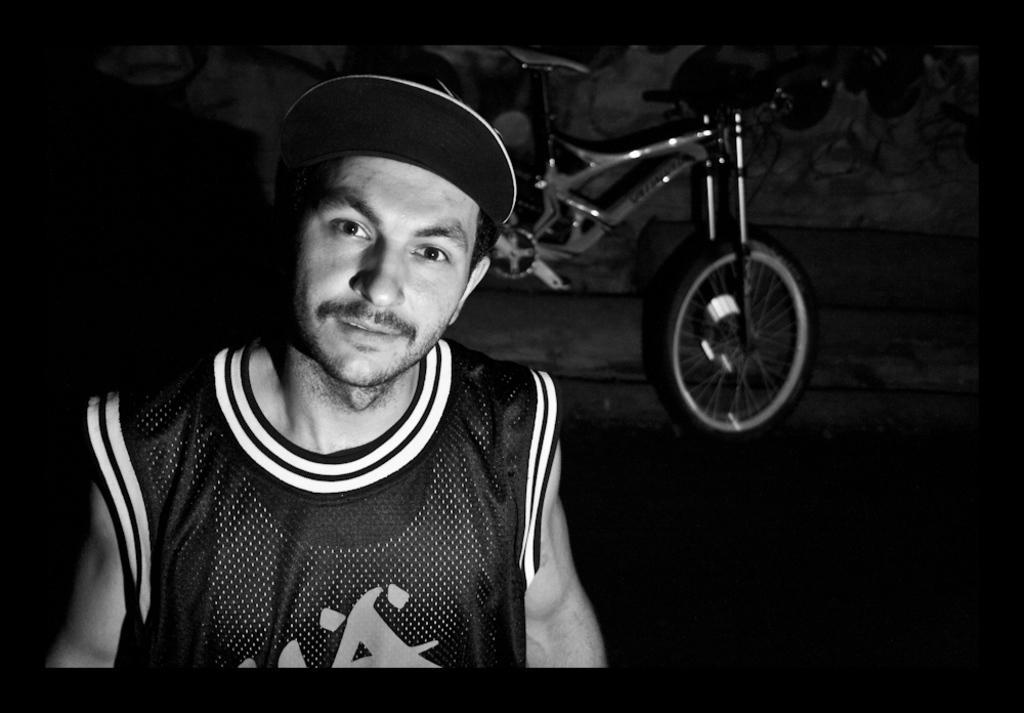How would you summarize this image in a sentence or two? This is a black and white pic. We can see a cap on the man's head. In the background we can see a bicycle, objects and looks like drawings on the wall. 